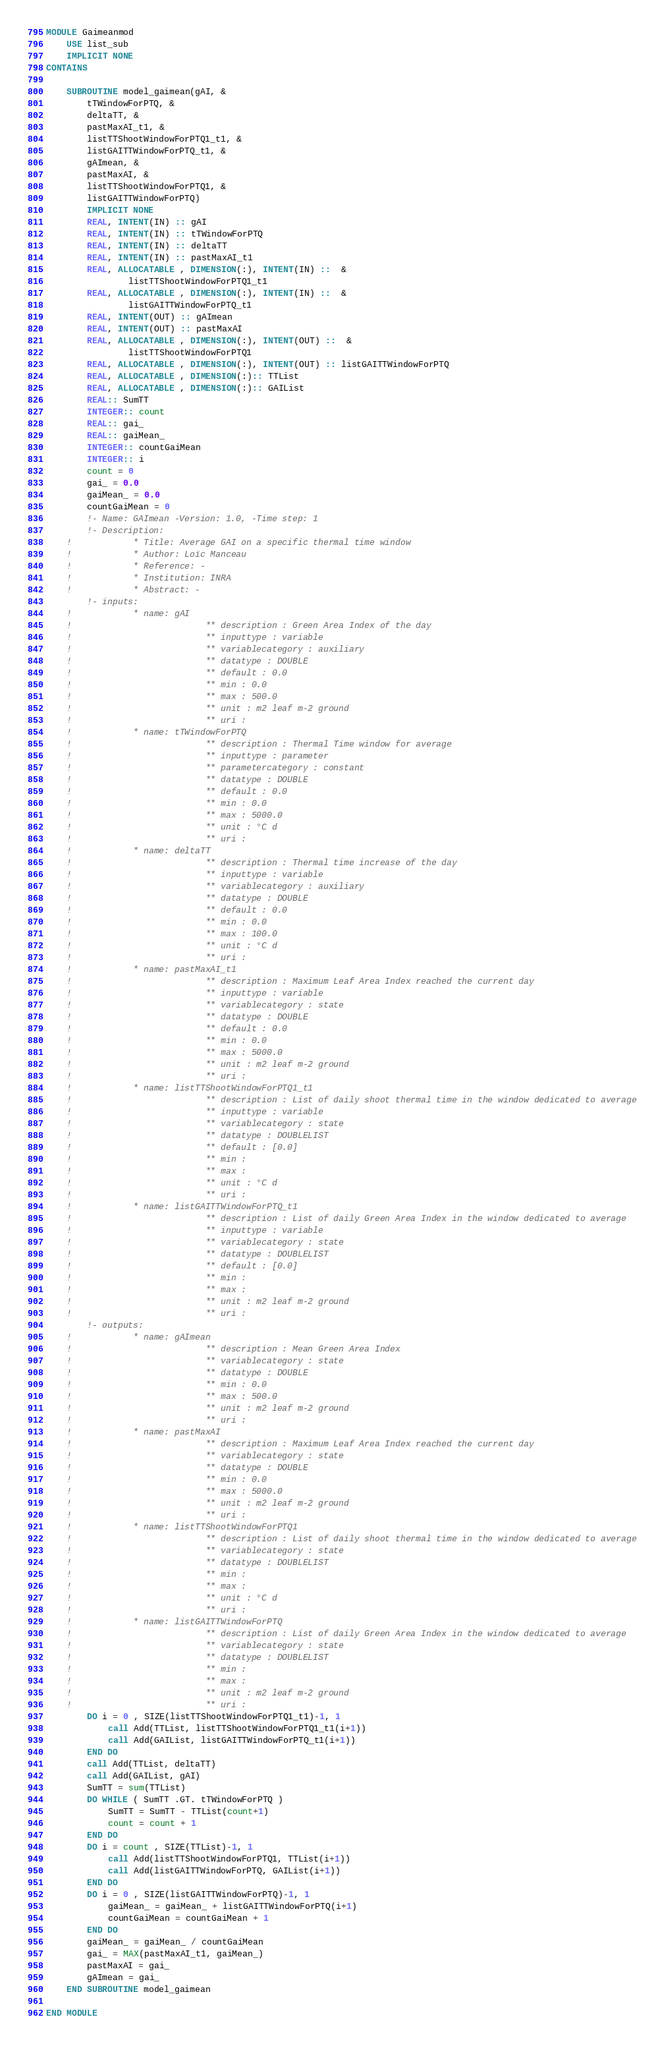<code> <loc_0><loc_0><loc_500><loc_500><_FORTRAN_>MODULE Gaimeanmod
    USE list_sub
    IMPLICIT NONE
CONTAINS

    SUBROUTINE model_gaimean(gAI, &
        tTWindowForPTQ, &
        deltaTT, &
        pastMaxAI_t1, &
        listTTShootWindowForPTQ1_t1, &
        listGAITTWindowForPTQ_t1, &
        gAImean, &
        pastMaxAI, &
        listTTShootWindowForPTQ1, &
        listGAITTWindowForPTQ)
        IMPLICIT NONE
        REAL, INTENT(IN) :: gAI
        REAL, INTENT(IN) :: tTWindowForPTQ
        REAL, INTENT(IN) :: deltaTT
        REAL, INTENT(IN) :: pastMaxAI_t1
        REAL, ALLOCATABLE , DIMENSION(:), INTENT(IN) ::  &
                listTTShootWindowForPTQ1_t1
        REAL, ALLOCATABLE , DIMENSION(:), INTENT(IN) ::  &
                listGAITTWindowForPTQ_t1
        REAL, INTENT(OUT) :: gAImean
        REAL, INTENT(OUT) :: pastMaxAI
        REAL, ALLOCATABLE , DIMENSION(:), INTENT(OUT) ::  &
                listTTShootWindowForPTQ1
        REAL, ALLOCATABLE , DIMENSION(:), INTENT(OUT) :: listGAITTWindowForPTQ
        REAL, ALLOCATABLE , DIMENSION(:):: TTList
        REAL, ALLOCATABLE , DIMENSION(:):: GAIList
        REAL:: SumTT
        INTEGER:: count
        REAL:: gai_
        REAL:: gaiMean_
        INTEGER:: countGaiMean
        INTEGER:: i
        count = 0
        gai_ = 0.0
        gaiMean_ = 0.0
        countGaiMean = 0
        !- Name: GAImean -Version: 1.0, -Time step: 1
        !- Description:
    !            * Title: Average GAI on a specific thermal time window
    !            * Author: Loïc Manceau
    !            * Reference: -
    !            * Institution: INRA
    !            * Abstract: -
        !- inputs:
    !            * name: gAI
    !                          ** description : Green Area Index of the day
    !                          ** inputtype : variable
    !                          ** variablecategory : auxiliary
    !                          ** datatype : DOUBLE
    !                          ** default : 0.0
    !                          ** min : 0.0
    !                          ** max : 500.0
    !                          ** unit : m2 leaf m-2 ground
    !                          ** uri : 
    !            * name: tTWindowForPTQ
    !                          ** description : Thermal Time window for average
    !                          ** inputtype : parameter
    !                          ** parametercategory : constant
    !                          ** datatype : DOUBLE
    !                          ** default : 0.0
    !                          ** min : 0.0
    !                          ** max : 5000.0
    !                          ** unit : °C d
    !                          ** uri : 
    !            * name: deltaTT
    !                          ** description : Thermal time increase of the day
    !                          ** inputtype : variable
    !                          ** variablecategory : auxiliary
    !                          ** datatype : DOUBLE
    !                          ** default : 0.0
    !                          ** min : 0.0
    !                          ** max : 100.0
    !                          ** unit : °C d
    !                          ** uri : 
    !            * name: pastMaxAI_t1
    !                          ** description : Maximum Leaf Area Index reached the current day
    !                          ** inputtype : variable
    !                          ** variablecategory : state
    !                          ** datatype : DOUBLE
    !                          ** default : 0.0
    !                          ** min : 0.0
    !                          ** max : 5000.0
    !                          ** unit : m2 leaf m-2 ground
    !                          ** uri : 
    !            * name: listTTShootWindowForPTQ1_t1
    !                          ** description : List of daily shoot thermal time in the window dedicated to average
    !                          ** inputtype : variable
    !                          ** variablecategory : state
    !                          ** datatype : DOUBLELIST
    !                          ** default : [0.0]
    !                          ** min : 
    !                          ** max : 
    !                          ** unit : °C d
    !                          ** uri : 
    !            * name: listGAITTWindowForPTQ_t1
    !                          ** description : List of daily Green Area Index in the window dedicated to average
    !                          ** inputtype : variable
    !                          ** variablecategory : state
    !                          ** datatype : DOUBLELIST
    !                          ** default : [0.0]
    !                          ** min : 
    !                          ** max : 
    !                          ** unit : m2 leaf m-2 ground
    !                          ** uri : 
        !- outputs:
    !            * name: gAImean
    !                          ** description : Mean Green Area Index
    !                          ** variablecategory : state
    !                          ** datatype : DOUBLE
    !                          ** min : 0.0
    !                          ** max : 500.0
    !                          ** unit : m2 leaf m-2 ground
    !                          ** uri : 
    !            * name: pastMaxAI
    !                          ** description : Maximum Leaf Area Index reached the current day
    !                          ** variablecategory : state
    !                          ** datatype : DOUBLE
    !                          ** min : 0.0
    !                          ** max : 5000.0
    !                          ** unit : m2 leaf m-2 ground
    !                          ** uri : 
    !            * name: listTTShootWindowForPTQ1
    !                          ** description : List of daily shoot thermal time in the window dedicated to average
    !                          ** variablecategory : state
    !                          ** datatype : DOUBLELIST
    !                          ** min : 
    !                          ** max : 
    !                          ** unit : °C d
    !                          ** uri : 
    !            * name: listGAITTWindowForPTQ
    !                          ** description : List of daily Green Area Index in the window dedicated to average
    !                          ** variablecategory : state
    !                          ** datatype : DOUBLELIST
    !                          ** min : 
    !                          ** max : 
    !                          ** unit : m2 leaf m-2 ground
    !                          ** uri : 
        DO i = 0 , SIZE(listTTShootWindowForPTQ1_t1)-1, 1
            call Add(TTList, listTTShootWindowForPTQ1_t1(i+1))
            call Add(GAIList, listGAITTWindowForPTQ_t1(i+1))
        END DO
        call Add(TTList, deltaTT)
        call Add(GAIList, gAI)
        SumTT = sum(TTList)
        DO WHILE ( SumTT .GT. tTWindowForPTQ )
            SumTT = SumTT - TTList(count+1)
            count = count + 1
        END DO
        DO i = count , SIZE(TTList)-1, 1
            call Add(listTTShootWindowForPTQ1, TTList(i+1))
            call Add(listGAITTWindowForPTQ, GAIList(i+1))
        END DO
        DO i = 0 , SIZE(listGAITTWindowForPTQ)-1, 1
            gaiMean_ = gaiMean_ + listGAITTWindowForPTQ(i+1)
            countGaiMean = countGaiMean + 1
        END DO
        gaiMean_ = gaiMean_ / countGaiMean
        gai_ = MAX(pastMaxAI_t1, gaiMean_)
        pastMaxAI = gai_
        gAImean = gai_
    END SUBROUTINE model_gaimean

END MODULE
</code> 